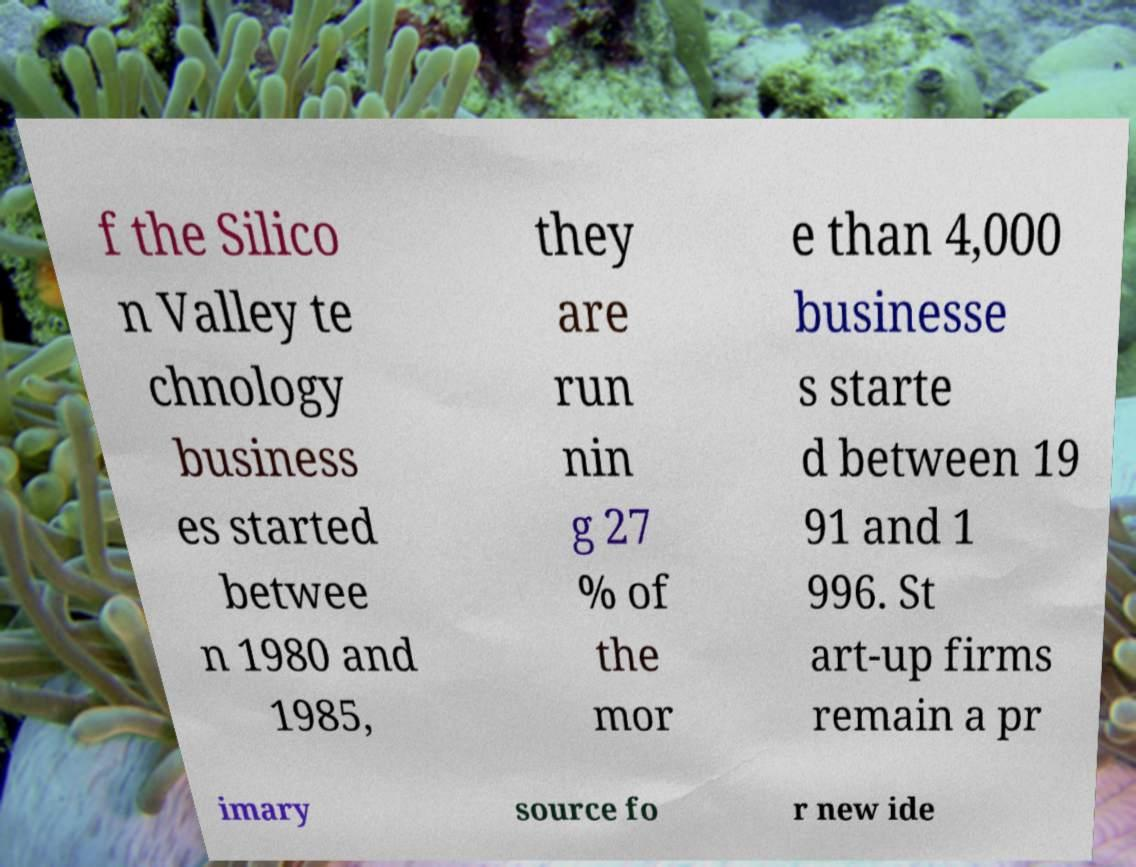What messages or text are displayed in this image? I need them in a readable, typed format. f the Silico n Valley te chnology business es started betwee n 1980 and 1985, they are run nin g 27 % of the mor e than 4,000 businesse s starte d between 19 91 and 1 996. St art-up firms remain a pr imary source fo r new ide 